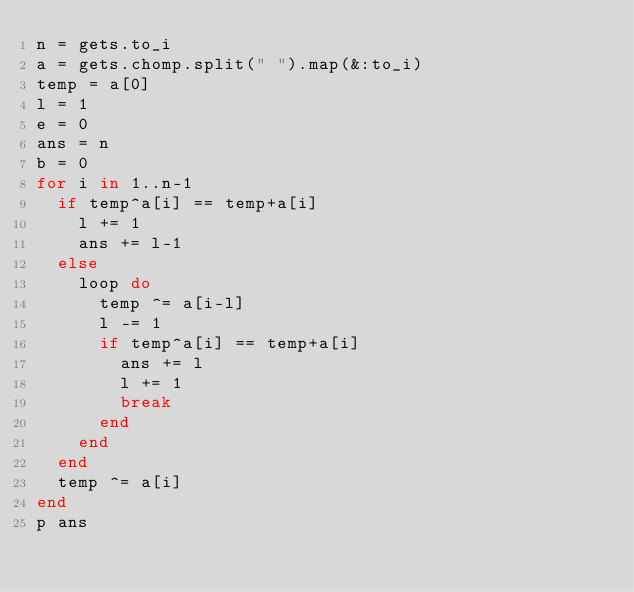Convert code to text. <code><loc_0><loc_0><loc_500><loc_500><_Ruby_>n = gets.to_i
a = gets.chomp.split(" ").map(&:to_i)
temp = a[0]
l = 1
e = 0
ans = n
b = 0
for i in 1..n-1
  if temp^a[i] == temp+a[i]
    l += 1
    ans += l-1
  else
    loop do
      temp ^= a[i-l]
      l -= 1
      if temp^a[i] == temp+a[i]
        ans += l
        l += 1
        break
      end
    end
  end
  temp ^= a[i]
end
p ans</code> 